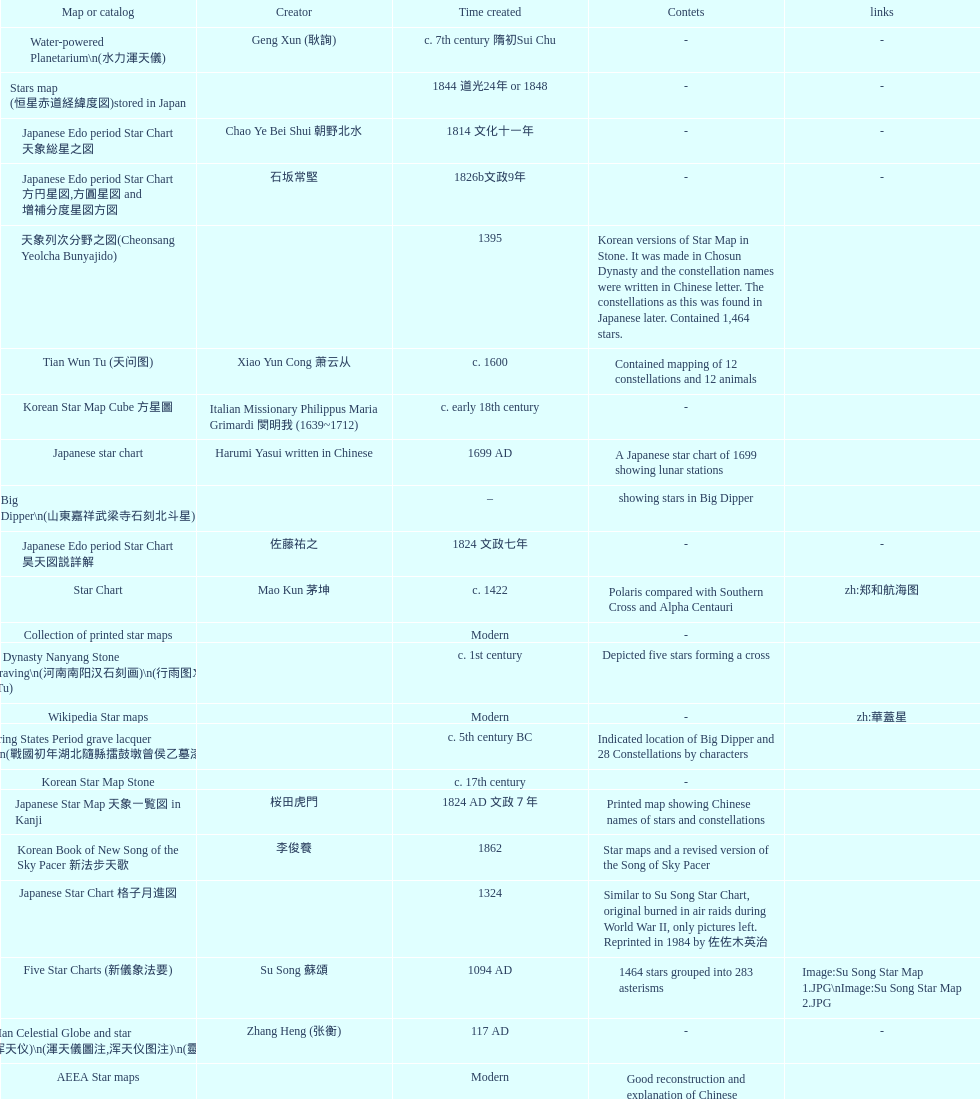Which was the first chinese star map known to have been created? M45 (伏羲星图Fuxixingtu). 